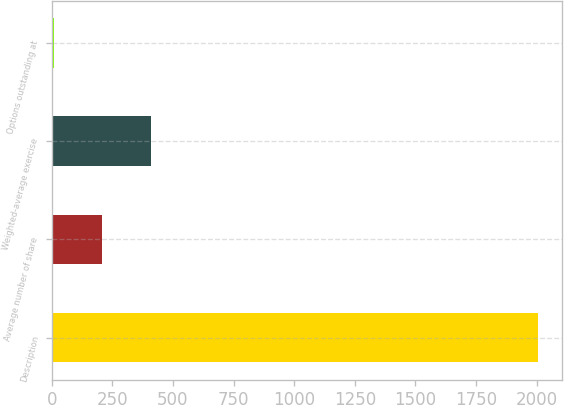<chart> <loc_0><loc_0><loc_500><loc_500><bar_chart><fcel>Description<fcel>Average number of share<fcel>Weighted-average exercise<fcel>Options outstanding at<nl><fcel>2005<fcel>208.42<fcel>408.04<fcel>8.8<nl></chart> 